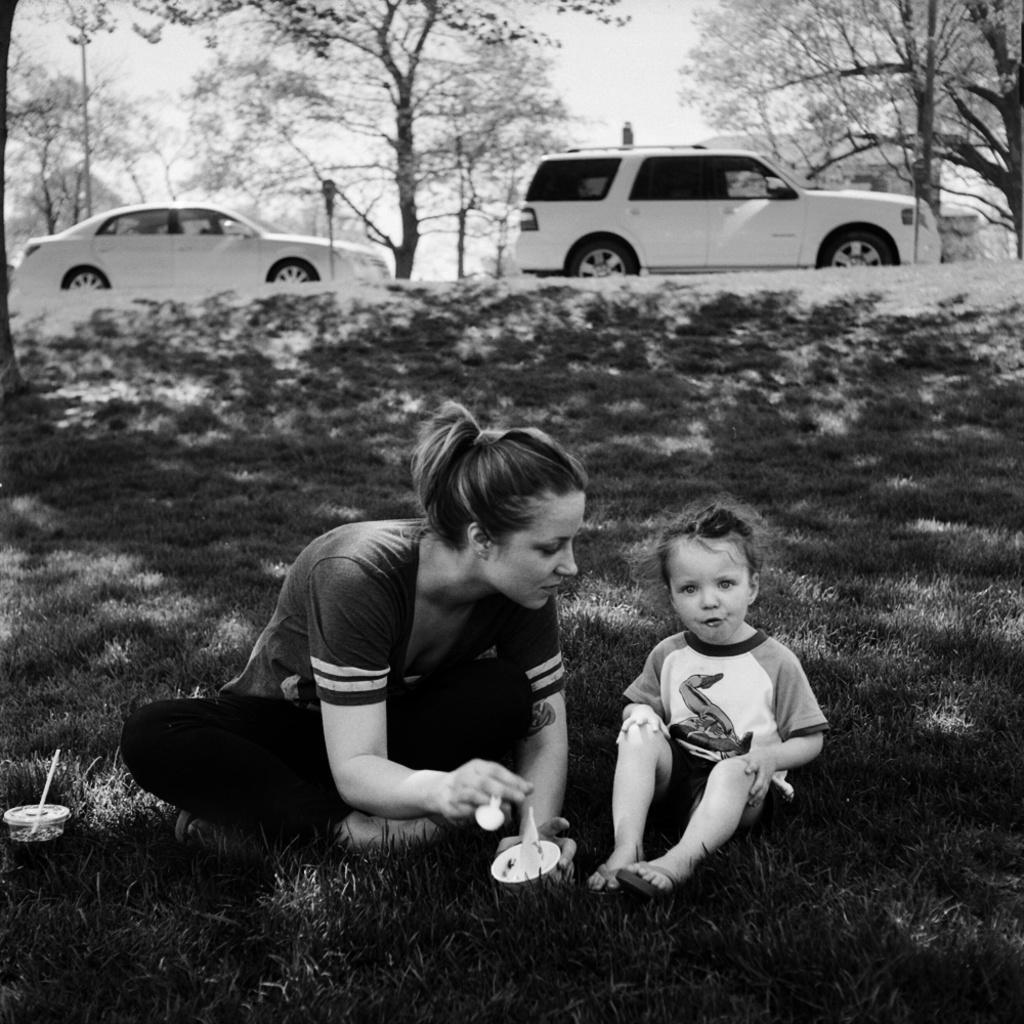Describe this image in one or two sentences. This is a black and white image. Here I can see a woman and a baby are sitting on the ground. The woman is holding a bowl and spoon in the hands and looking at the baby. On the ground, I can see the grass. In the background there are two cars and some trees. 